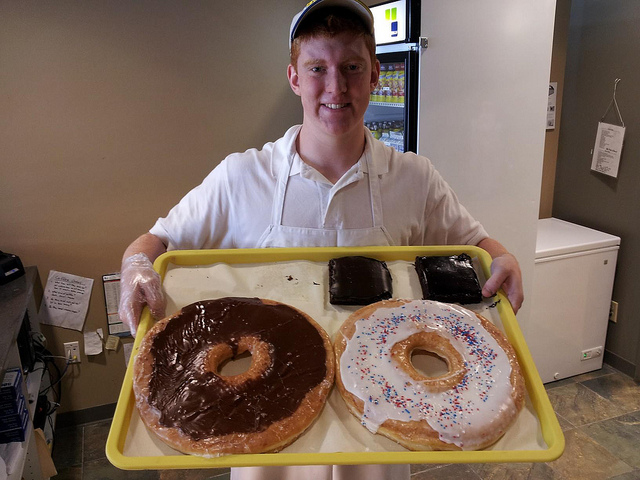How does the size of the items on the tray compare to the typical item of this type? The items on the tray are significantly oversized, many times larger than a typical item of this type, providing an amusing visual twist on ordinary bakery goods. 